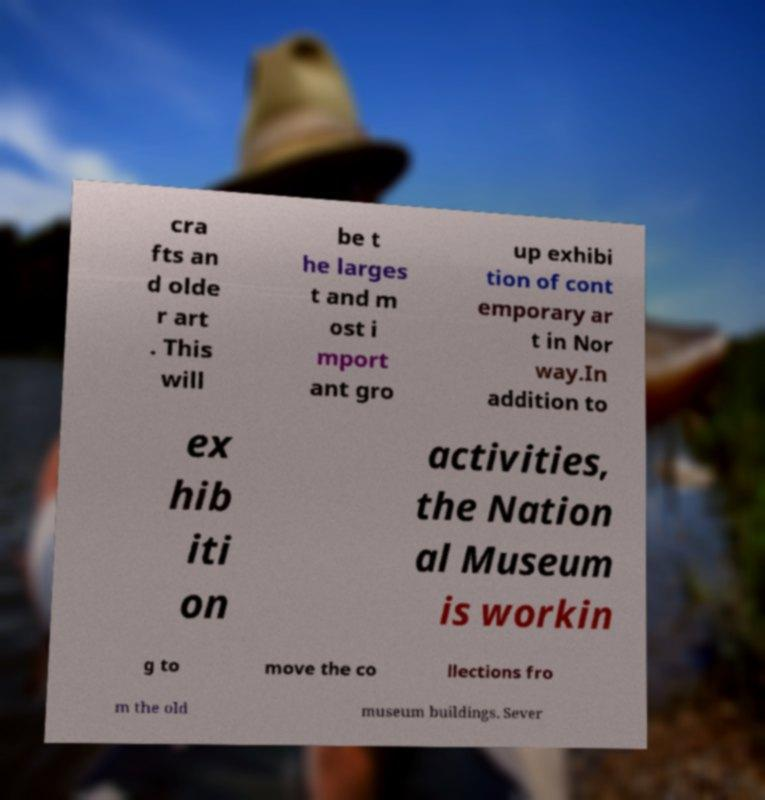For documentation purposes, I need the text within this image transcribed. Could you provide that? cra fts an d olde r art . This will be t he larges t and m ost i mport ant gro up exhibi tion of cont emporary ar t in Nor way.In addition to ex hib iti on activities, the Nation al Museum is workin g to move the co llections fro m the old museum buildings. Sever 